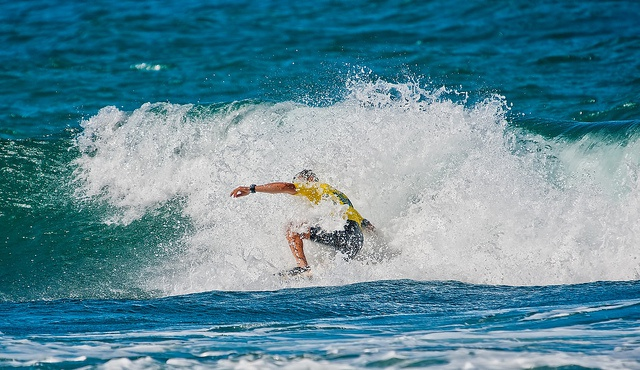Describe the objects in this image and their specific colors. I can see people in blue, gray, darkgray, black, and brown tones and surfboard in blue, lightgray, and darkgray tones in this image. 